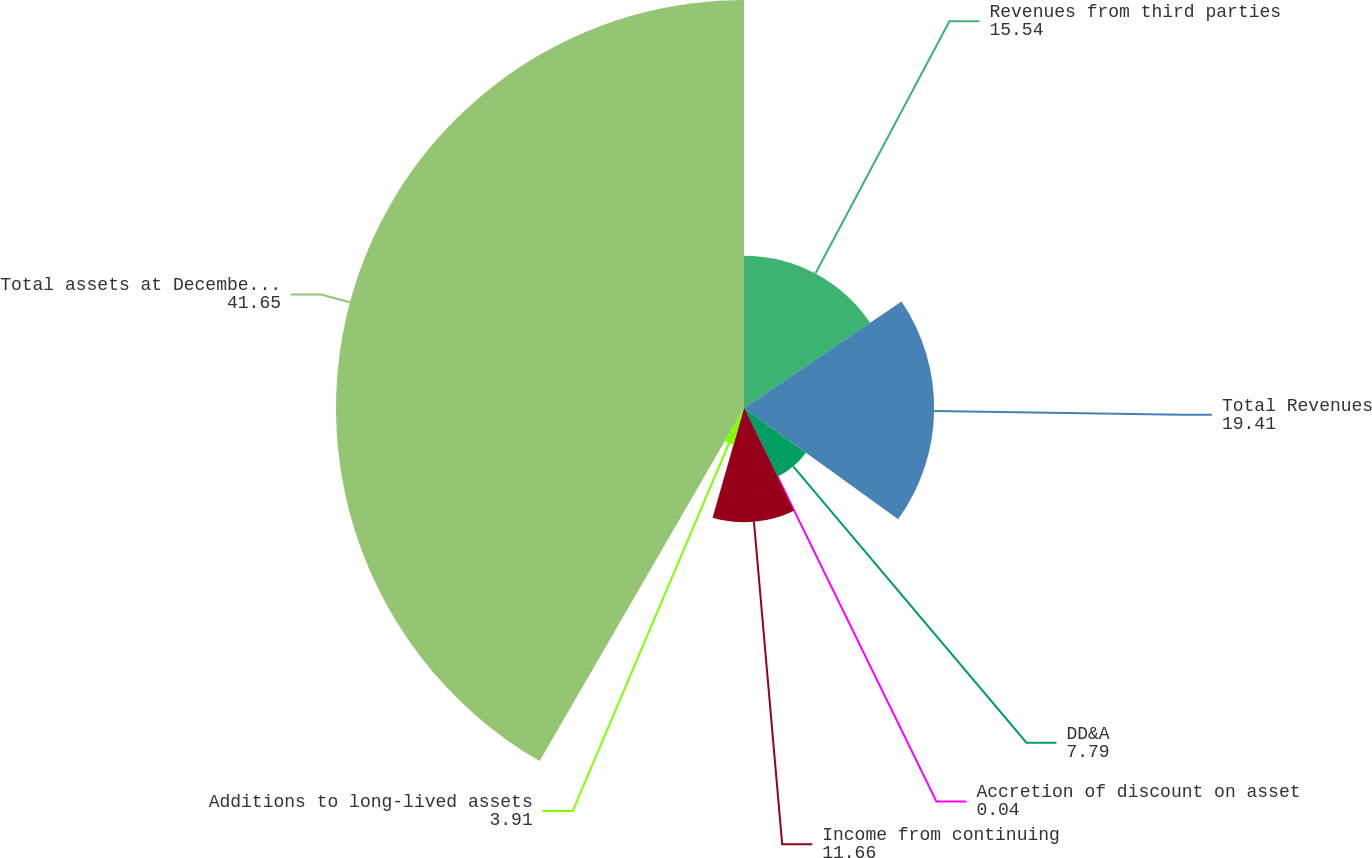Convert chart to OTSL. <chart><loc_0><loc_0><loc_500><loc_500><pie_chart><fcel>Revenues from third parties<fcel>Total Revenues<fcel>DD&A<fcel>Accretion of discount on asset<fcel>Income from continuing<fcel>Additions to long-lived assets<fcel>Total assets at December 31<nl><fcel>15.54%<fcel>19.41%<fcel>7.79%<fcel>0.04%<fcel>11.66%<fcel>3.91%<fcel>41.65%<nl></chart> 